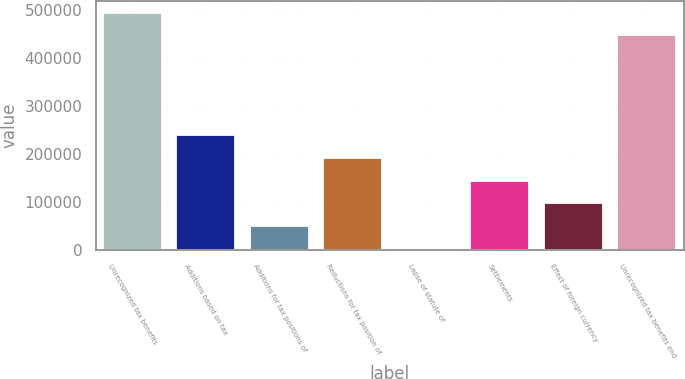Convert chart to OTSL. <chart><loc_0><loc_0><loc_500><loc_500><bar_chart><fcel>Unrecognized tax benefits<fcel>Additions based on tax<fcel>Additions for tax positions of<fcel>Reductions for tax position of<fcel>Lapse of statute of<fcel>Settlements<fcel>Effect of foreign currency<fcel>Unrecognized tax benefits end<nl><fcel>494126<fcel>238940<fcel>50005.5<fcel>191706<fcel>2772<fcel>144472<fcel>97239<fcel>446892<nl></chart> 